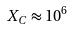Convert formula to latex. <formula><loc_0><loc_0><loc_500><loc_500>X _ { C } \approx 1 0 ^ { 6 }</formula> 